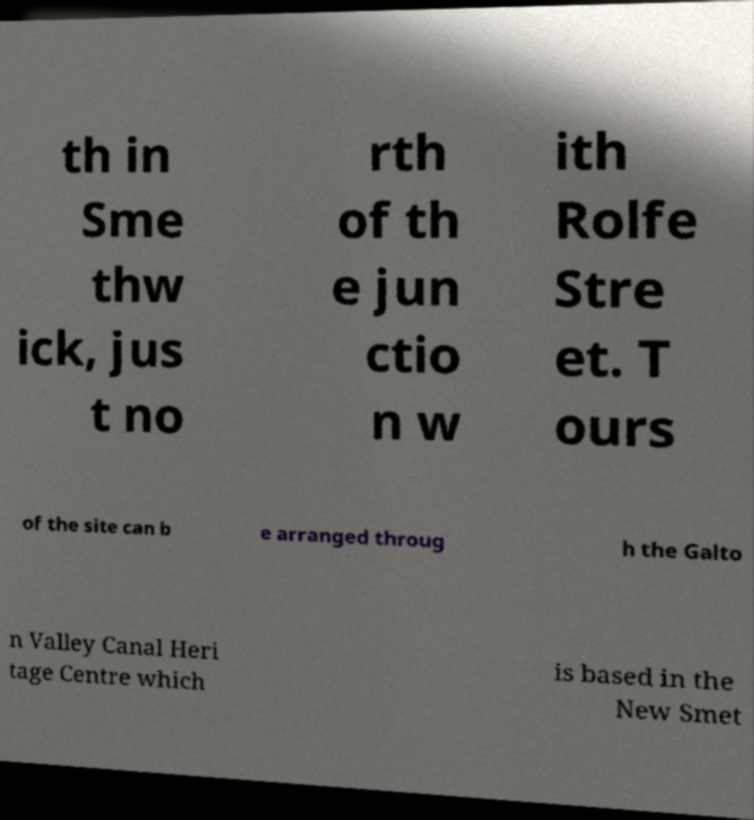There's text embedded in this image that I need extracted. Can you transcribe it verbatim? th in Sme thw ick, jus t no rth of th e jun ctio n w ith Rolfe Stre et. T ours of the site can b e arranged throug h the Galto n Valley Canal Heri tage Centre which is based in the New Smet 